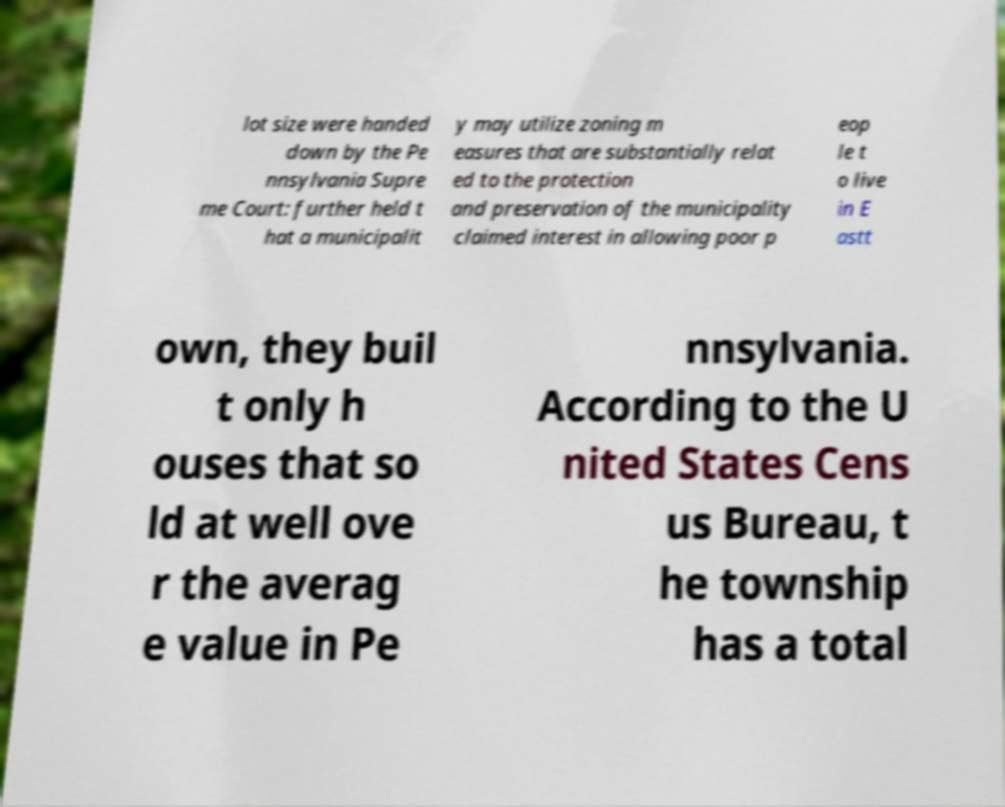Please read and relay the text visible in this image. What does it say? lot size were handed down by the Pe nnsylvania Supre me Court: further held t hat a municipalit y may utilize zoning m easures that are substantially relat ed to the protection and preservation of the municipality claimed interest in allowing poor p eop le t o live in E astt own, they buil t only h ouses that so ld at well ove r the averag e value in Pe nnsylvania. According to the U nited States Cens us Bureau, t he township has a total 